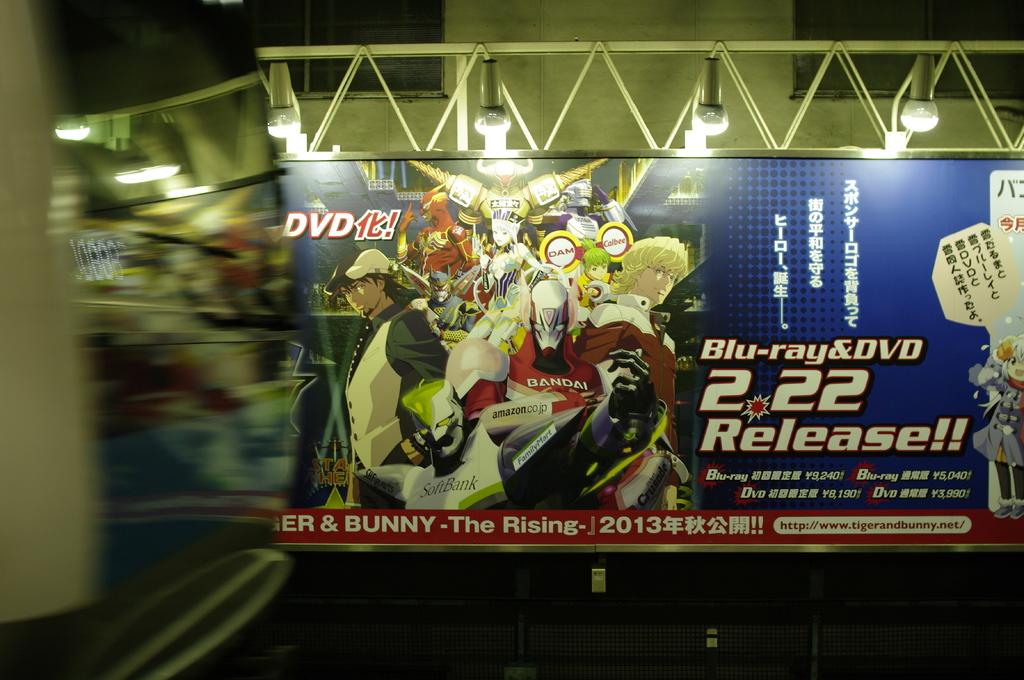Is the movie released?
Provide a succinct answer. Yes. What year is on the advertisement?
Offer a very short reply. 2013. 